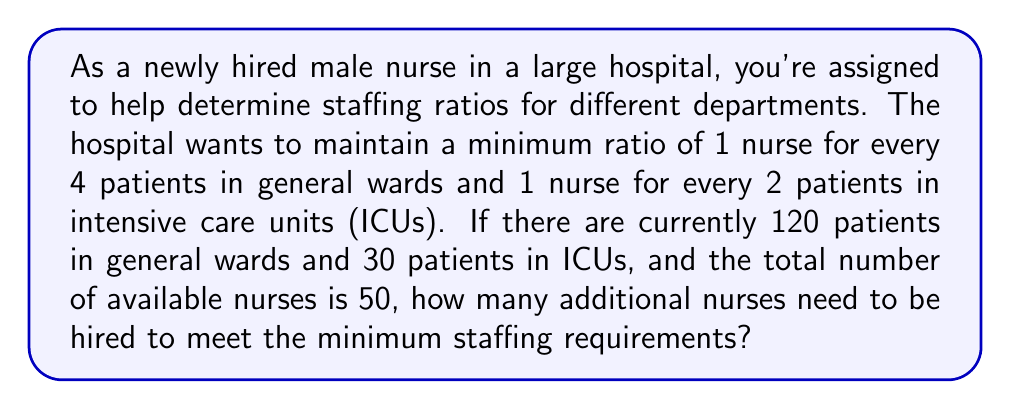Can you solve this math problem? Let's approach this step-by-step:

1. Set up variables:
   Let $x$ be the number of nurses in general wards
   Let $y$ be the number of nurses in ICUs

2. Create equations based on the given ratios:
   For general wards: $\frac{120}{x} \leq 4$ or $x \geq 30$
   For ICUs: $\frac{30}{y} \leq 2$ or $y \geq 15$

3. The total number of nurses needed is $x + y$

4. We need to find the minimum values that satisfy these inequalities:
   $x = 30$ (minimum for general wards)
   $y = 15$ (minimum for ICUs)

5. Calculate the total minimum number of nurses required:
   Total required = $x + y = 30 + 15 = 45$

6. Compare with the current number of available nurses:
   Additional nurses needed = Total required - Available nurses
   $= 45 - 50 = -5$

Since the result is negative, it means the hospital already has more than the minimum required nurses.
Answer: 0 additional nurses 